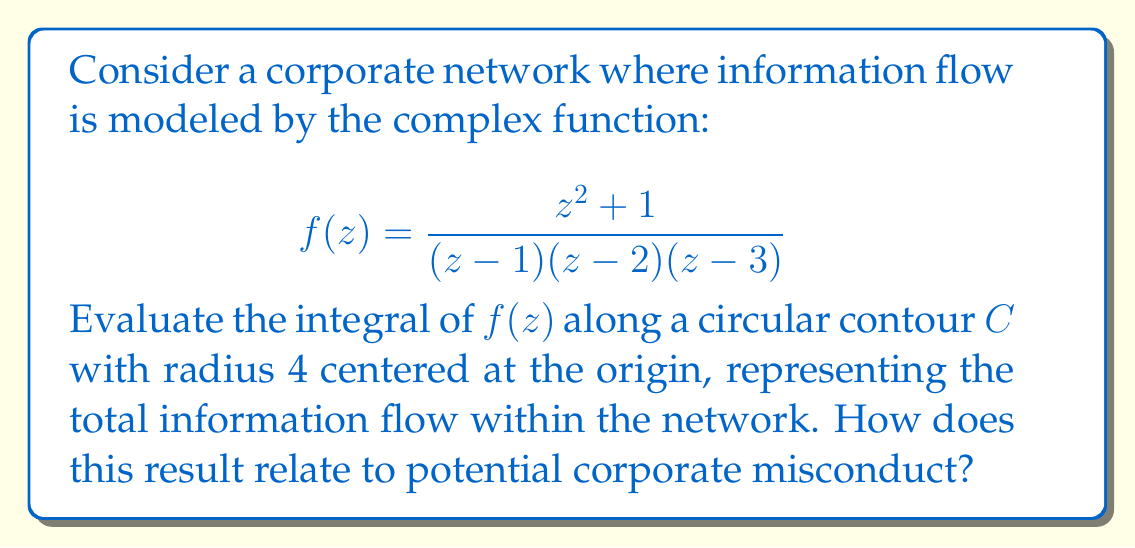What is the answer to this math problem? To solve this problem, we'll use the Residue Theorem from complex analysis. The steps are as follows:

1) First, we identify the poles of the function. These are at $z=1$, $z=2$, and $z=3$. All of these poles are simple and lie within our contour.

2) The Residue Theorem states that for a function $f(z)$ that is analytic except for isolated singularities inside a simple closed contour $C$:

   $$\oint_C f(z) dz = 2\pi i \sum \text{Res}(f, a_k)$$

   where $a_k$ are the singularities of $f(z)$ inside $C$.

3) We need to calculate the residues at each pole:

   For $z=1$: $\text{Res}(f,1) = \lim_{z \to 1} (z-1)f(z) = \frac{2}{(1-2)(1-3)} = -\frac{1}{2}$

   For $z=2$: $\text{Res}(f,2) = \lim_{z \to 2} (z-2)f(z) = \frac{5}{(2-1)(2-3)} = 5$

   For $z=3$: $\text{Res}(f,3) = \lim_{z \to 3} (z-3)f(z) = \frac{10}{(3-1)(3-2)} = 5$

4) Summing these residues and applying the Residue Theorem:

   $$\oint_C f(z) dz = 2\pi i (-\frac{1}{2} + 5 + 5) = 2\pi i (\frac{19}{2}) = 19\pi i$$

5) This result represents the total information flow in the network. The imaginary nature of the result suggests a cyclical or oscillatory behavior in the information flow.

6) In the context of corporate misconduct, this could be interpreted as follows:
   - The magnitude (19π) might represent the volume of information circulating.
   - The imaginary nature could suggest hidden or obscured information flows.
   - The three poles could represent key points in the network where information is concentrated or manipulated.
   - The residue at $z=1$ being negative while the others are positive could indicate a point of information leakage or whistleblowing.

This mathematical model provides a framework for analyzing complex information flows that could be indicative of corporate misconduct, such as insider trading, fraud, or cover-ups.
Answer: The integral of $f(z)$ along the contour $C$ is $19\pi i$. 